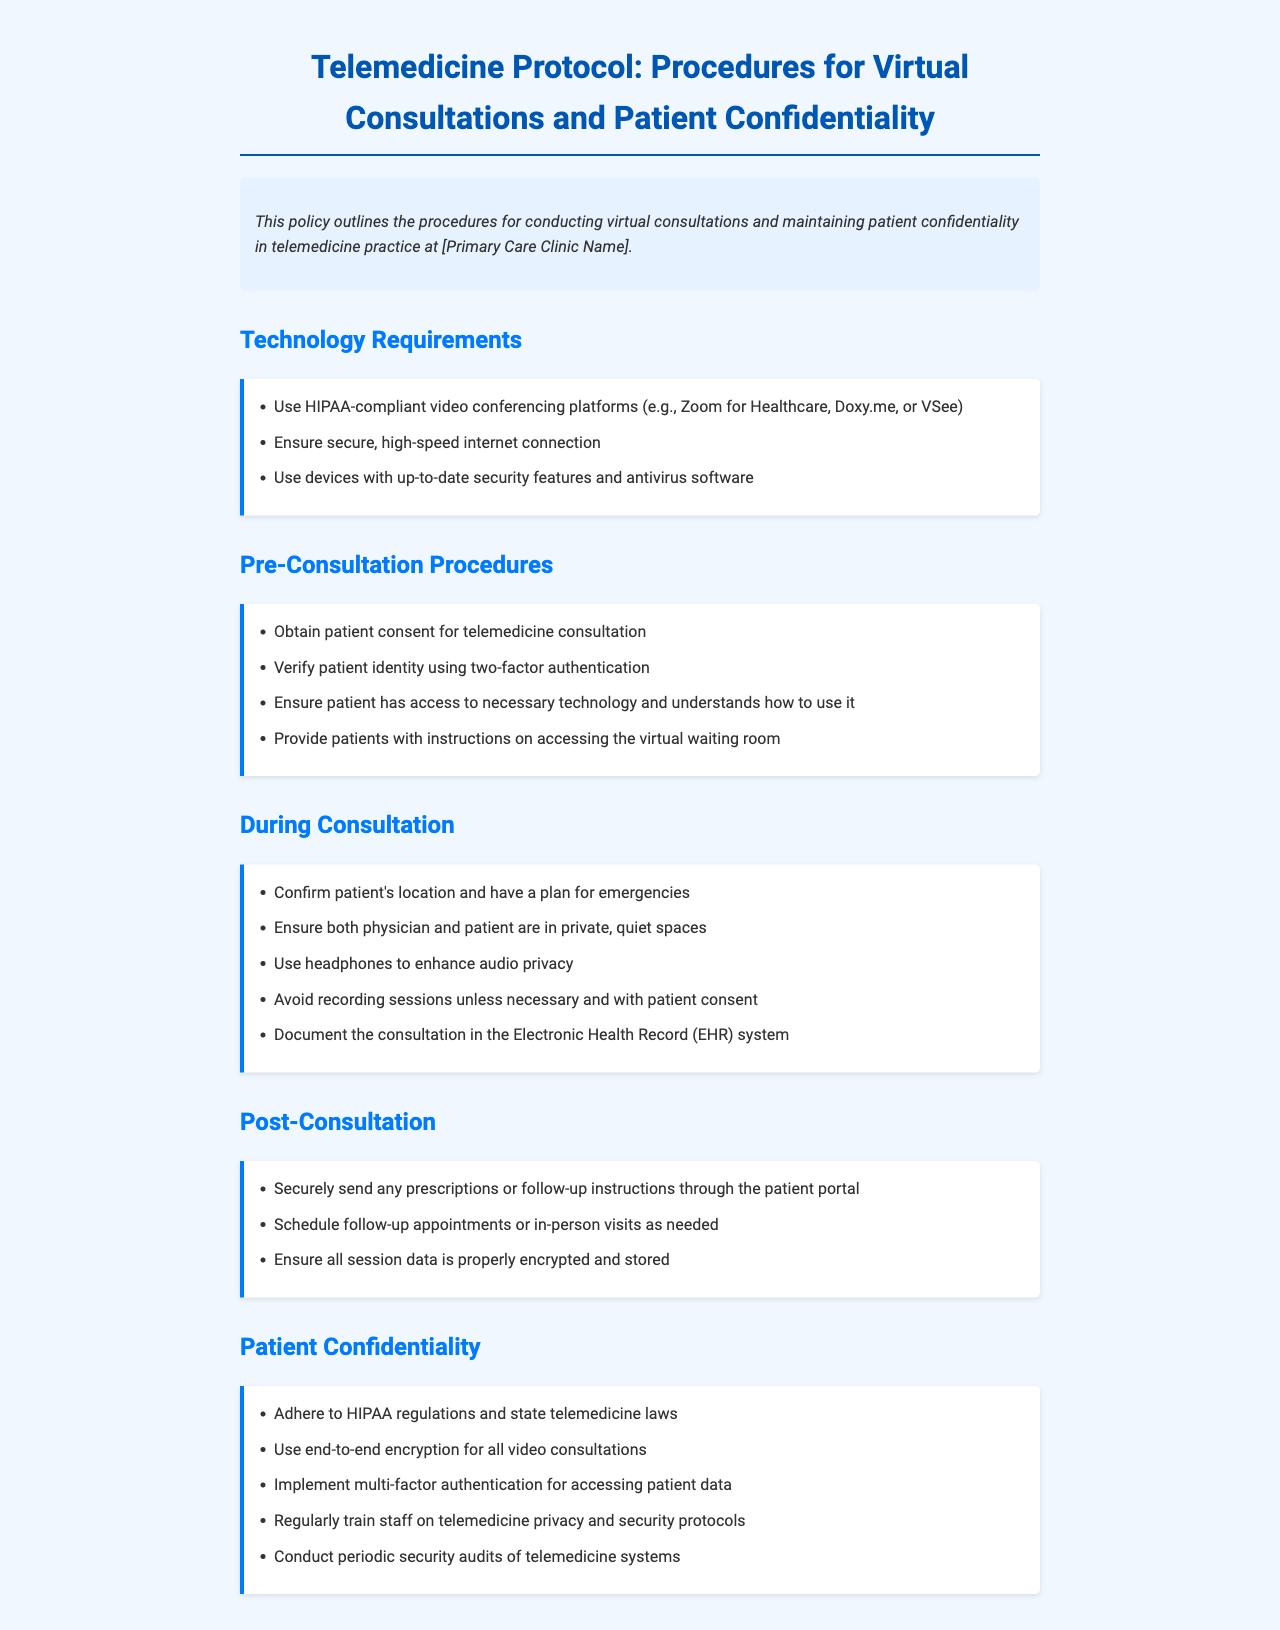What are the HIPAA-compliant video conferencing platforms mentioned? The document lists specific platforms deemed HIPAA-compliant for telemedicine consultations.
Answer: Zoom for Healthcare, Doxy.me, VSee What must be ensured for patient identity verification? The protocol requires a specific method for confirming the identity of the patient before a consultation.
Answer: Two-factor authentication What should be used to enhance audio privacy during consultation? This refers to an accessory that can be employed during virtual consultations to ensure that sound quality and confidentiality are maintained.
Answer: Headphones What is a post-consultation procedure regarding prescriptions? This outlines a specific action that must be taken to provide prescription information securely after a consultation.
Answer: Securely send through the patient portal What must staff regularly train on? The document specifies a particular area of knowledge that staff need continual education about to ensure patient privacy.
Answer: Telemedicine privacy and security protocols Why is it important to confirm the patient's location during a consultation? The document addresses a reason for needing this confirmation to address potential emergencies.
Answer: Emergency planning How should session data be stored post-consultation? This describes the necessary action to protect patient information after a telemedicine session concludes.
Answer: Properly encrypted and stored What is the purpose of conducting periodic security audits? This refers to the rationale provided in the document for reviewing the telemedicine systems for vulnerabilities.
Answer: Security checks What is the main purpose of this policy document? The document has a specific overall objective that outlines its importance in telemedicine practice.
Answer: Conducting virtual consultations and maintaining patient confidentiality 